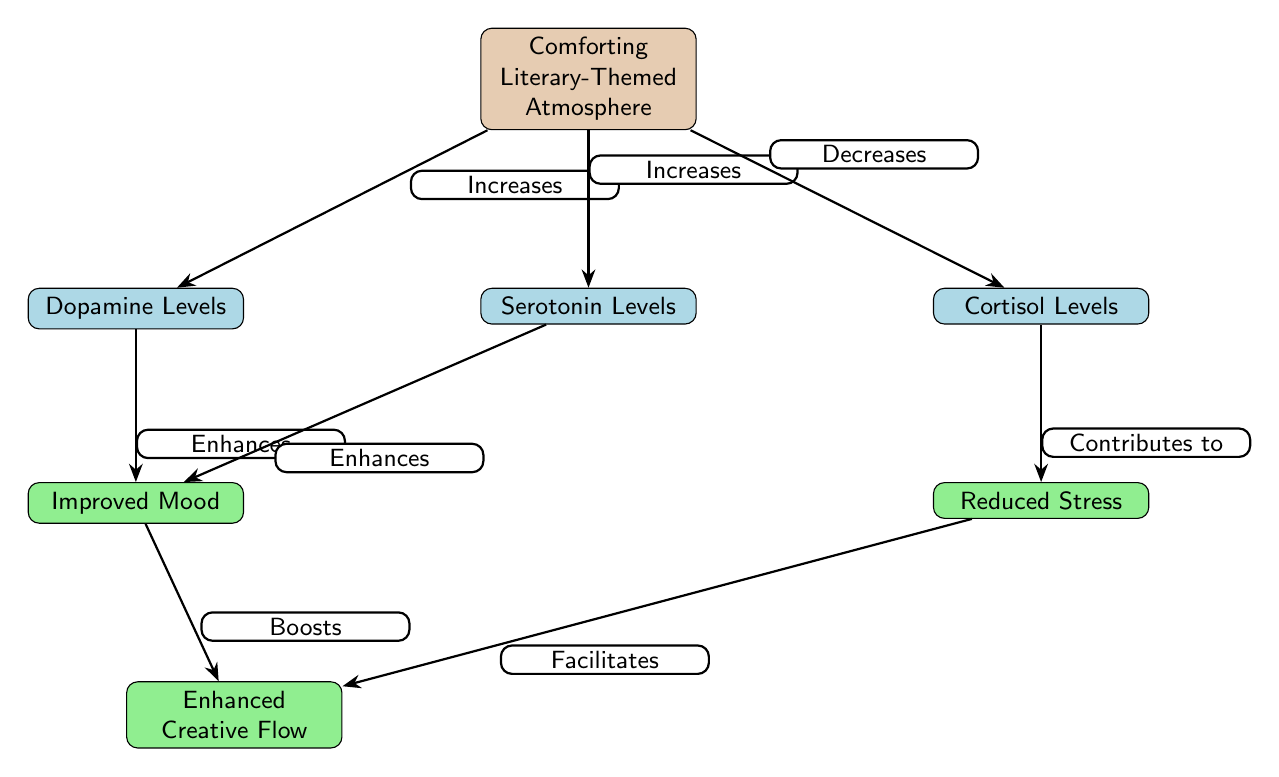What is the main environment discussed in the diagram? The diagram identifies the main environment as a "Comforting Literary-Themed Atmosphere," which is represented by the top node.
Answer: Comforting Literary-Themed Atmosphere How many neurotransmitter levels are shown in the diagram? There are three neurotransmitter levels shown in the diagram: Dopamine Levels, Serotonin Levels, and Cortisol Levels. By counting the nodes positioned below the main environment node, we find three nodes.
Answer: 3 What effect does the comforting literary-themed atmosphere have on dopamine levels? The diagram states that the comforting literary-themed atmosphere "Increases" dopamine levels, as indicated by the directed edge labeled "Increases" from the main environment to the dopamine node.
Answer: Increases Which outcome is directly linked to reduced cortisol levels? The diagram shows that the "Reduced Stress" outcome is directly linked to the "Cortisol Levels" node, indicated by the directed edge labeled "Contributes to" from cortisol to stress.
Answer: Reduced Stress What two factors enhance mood in this diagram? The two factors that enhance mood are "Dopamine Levels" and "Serotonin Levels." Both have directed edges leading to the "Improved Mood" node, each labeled with "Enhances."
Answer: Dopamine Levels and Serotonin Levels If cortisol levels decrease, what implication does that have on stress levels? According to the flow of the diagram, the decrease in cortisol levels contributes to stress, as indicated by the edge from cortisol to the stress node labeled "Contributes to." Thus, it suggests that decreased cortisol is associated with reduced stress.
Answer: Contributes to Which two outcomes facilitate enhanced creative flow? The "Reduced Stress" and "Improved Mood" outcomes both facilitate enhanced creative flow, as shown by the directed edges leading from these nodes to the "Enhanced Creative Flow" node, with the stress node labeled "Facilitates" and mood node labeled "Boosts."
Answer: Reduced Stress and Improved Mood What is the relationship between serotonin levels and mood? The relationship is that serotonin levels "Enhance" mood, which is indicated by the directed edge from the serotonin node to the mood node.
Answer: Enhances What happens to cortisol levels in this environment? The diagram states that cortisol levels "Decreases" in a comforting literary-themed atmosphere, which is represented by the directed edge from the environment node to the cortisol node.
Answer: Decreases 